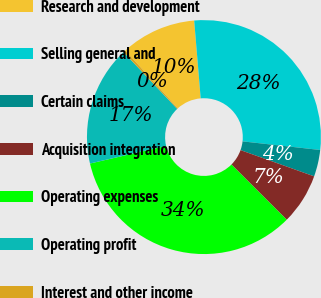Convert chart to OTSL. <chart><loc_0><loc_0><loc_500><loc_500><pie_chart><fcel>Research and development<fcel>Selling general and<fcel>Certain claims<fcel>Acquisition integration<fcel>Operating expenses<fcel>Operating profit<fcel>Interest and other income<nl><fcel>10.4%<fcel>28.09%<fcel>3.69%<fcel>7.04%<fcel>33.88%<fcel>16.57%<fcel>0.33%<nl></chart> 